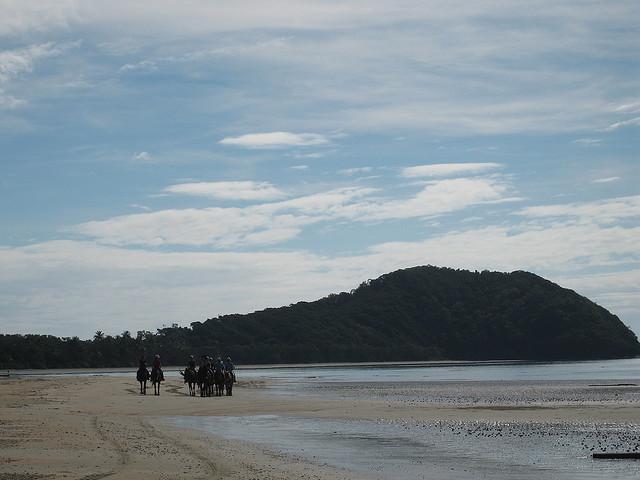Are there any horses?
Concise answer only. Yes. Is it foggy on the mountain tops?
Answer briefly. No. Are these people close to the camera?
Give a very brief answer. No. Are the people near the coast?
Write a very short answer. Yes. 